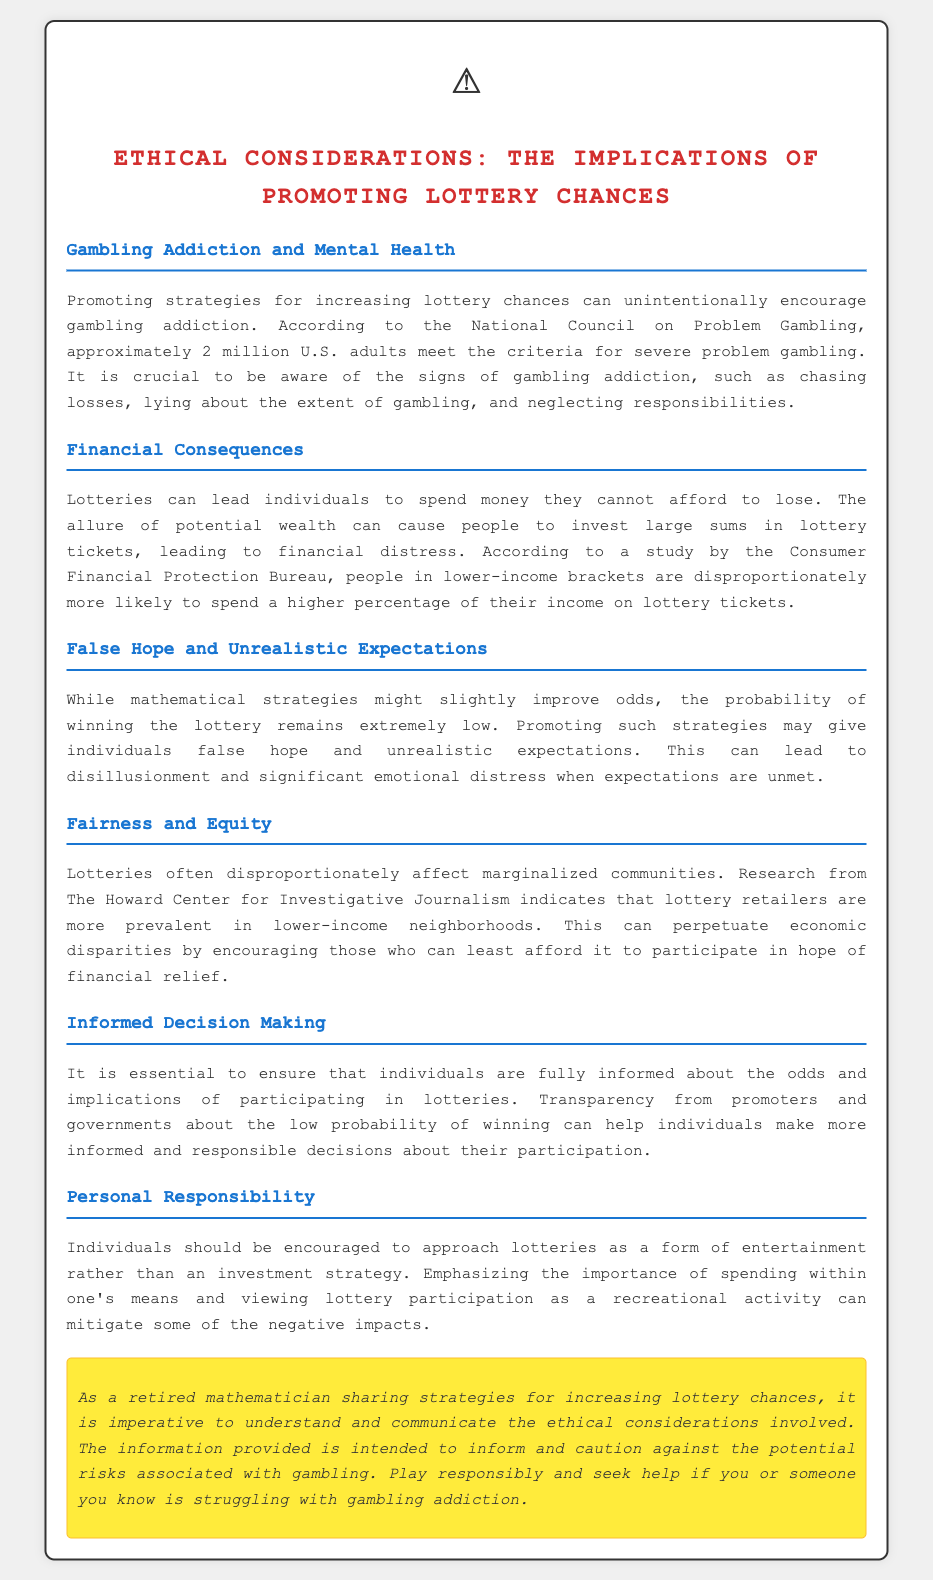What organization reported on gambling addiction? The National Council on Problem Gambling provides data on gambling addiction.
Answer: National Council on Problem Gambling How many adults meet the criteria for severe problem gambling in the U.S.? The document states that approximately 2 million U.S. adults meet the criteria for gambling addiction.
Answer: 2 million Which income group spends a higher percentage of their income on lottery tickets? The study from the Consumer Financial Protection Bureau indicates that lower-income brackets disproportionately spend more on lottery tickets.
Answer: Lower-income brackets What can the promotion of lottery strategies lead to? The promotion of lottery strategies can give individuals false hope and unrealistic expectations.
Answer: False hope What should individuals view lottery participation as? The document emphasizes that individuals should approach lotteries as a form of entertainment rather than an investment strategy.
Answer: Entertainment What is a critical ethical consideration raised in the document? The document discusses the ethical implications of promoting lottery chances, including gambling addiction, financial consequences, and fairness.
Answer: Gambling addiction What is particularly prevalent in lower-income neighborhoods? The Howard Center for Investigative Journalism indicates that lottery retailers are more prevalent in lower-income neighborhoods.
Answer: Lottery retailers What is a source of emotional distress when lottery expectations are unmet? Unrealistic expectations from promoting strategies can lead to disillusionment and significant emotional distress.
Answer: Disillusionment 